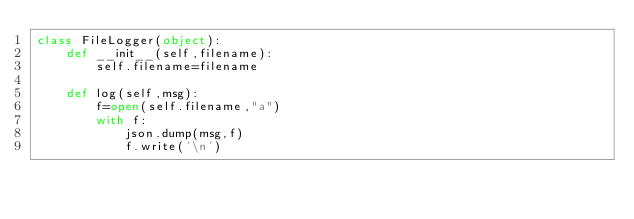Convert code to text. <code><loc_0><loc_0><loc_500><loc_500><_Python_>class FileLogger(object):
    def __init__(self,filename):
        self.filename=filename

    def log(self,msg):
        f=open(self.filename,"a")
        with f:
            json.dump(msg,f)
            f.write('\n')
</code> 